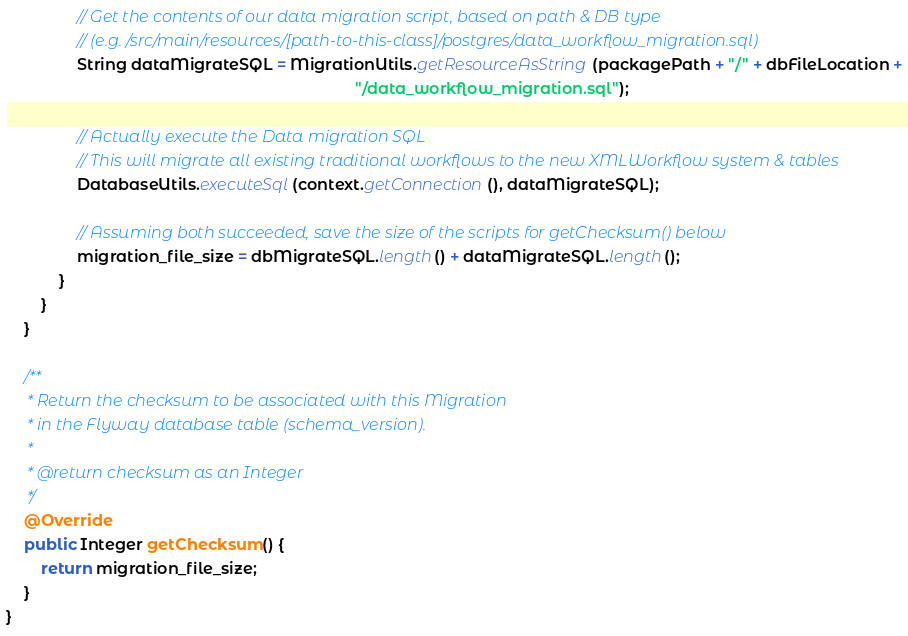<code> <loc_0><loc_0><loc_500><loc_500><_Java_>
                // Get the contents of our data migration script, based on path & DB type
                // (e.g. /src/main/resources/[path-to-this-class]/postgres/data_workflow_migration.sql)
                String dataMigrateSQL = MigrationUtils.getResourceAsString(packagePath + "/" + dbFileLocation +
                                                                               "/data_workflow_migration.sql");

                // Actually execute the Data migration SQL
                // This will migrate all existing traditional workflows to the new XMLWorkflow system & tables
                DatabaseUtils.executeSql(context.getConnection(), dataMigrateSQL);

                // Assuming both succeeded, save the size of the scripts for getChecksum() below
                migration_file_size = dbMigrateSQL.length() + dataMigrateSQL.length();
            }
        }
    }

    /**
     * Return the checksum to be associated with this Migration
     * in the Flyway database table (schema_version).
     *
     * @return checksum as an Integer
     */
    @Override
    public Integer getChecksum() {
        return migration_file_size;
    }
}
</code> 